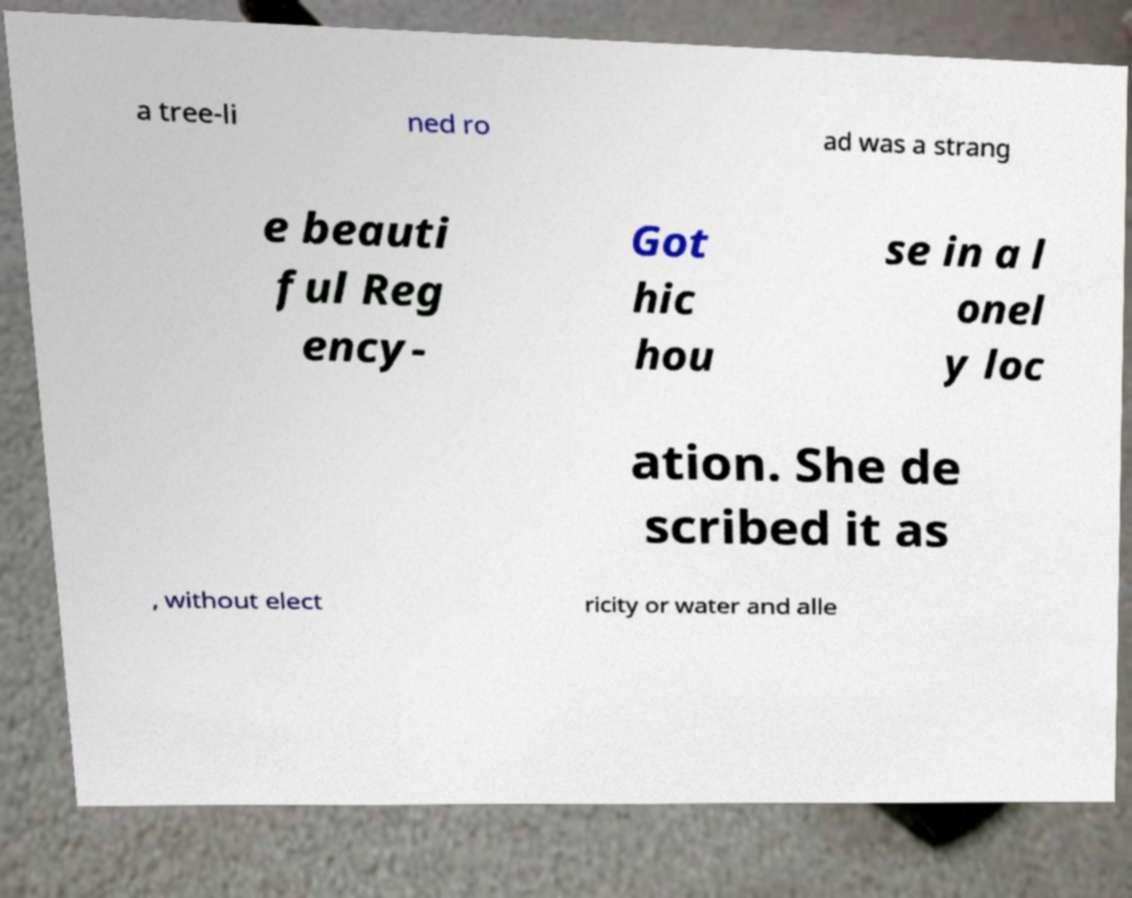Can you read and provide the text displayed in the image?This photo seems to have some interesting text. Can you extract and type it out for me? a tree-li ned ro ad was a strang e beauti ful Reg ency- Got hic hou se in a l onel y loc ation. She de scribed it as , without elect ricity or water and alle 